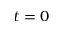<formula> <loc_0><loc_0><loc_500><loc_500>t = 0</formula> 